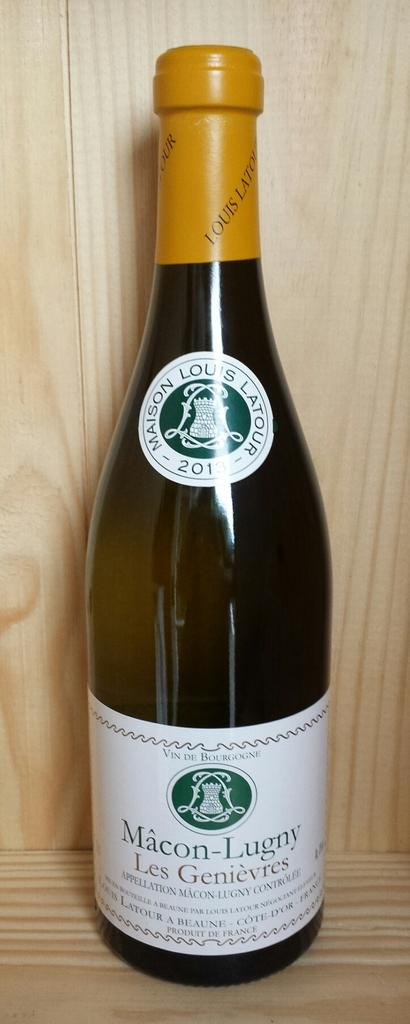<image>
Summarize the visual content of the image. A bottle of Macon Lugny wine that is still corked. 